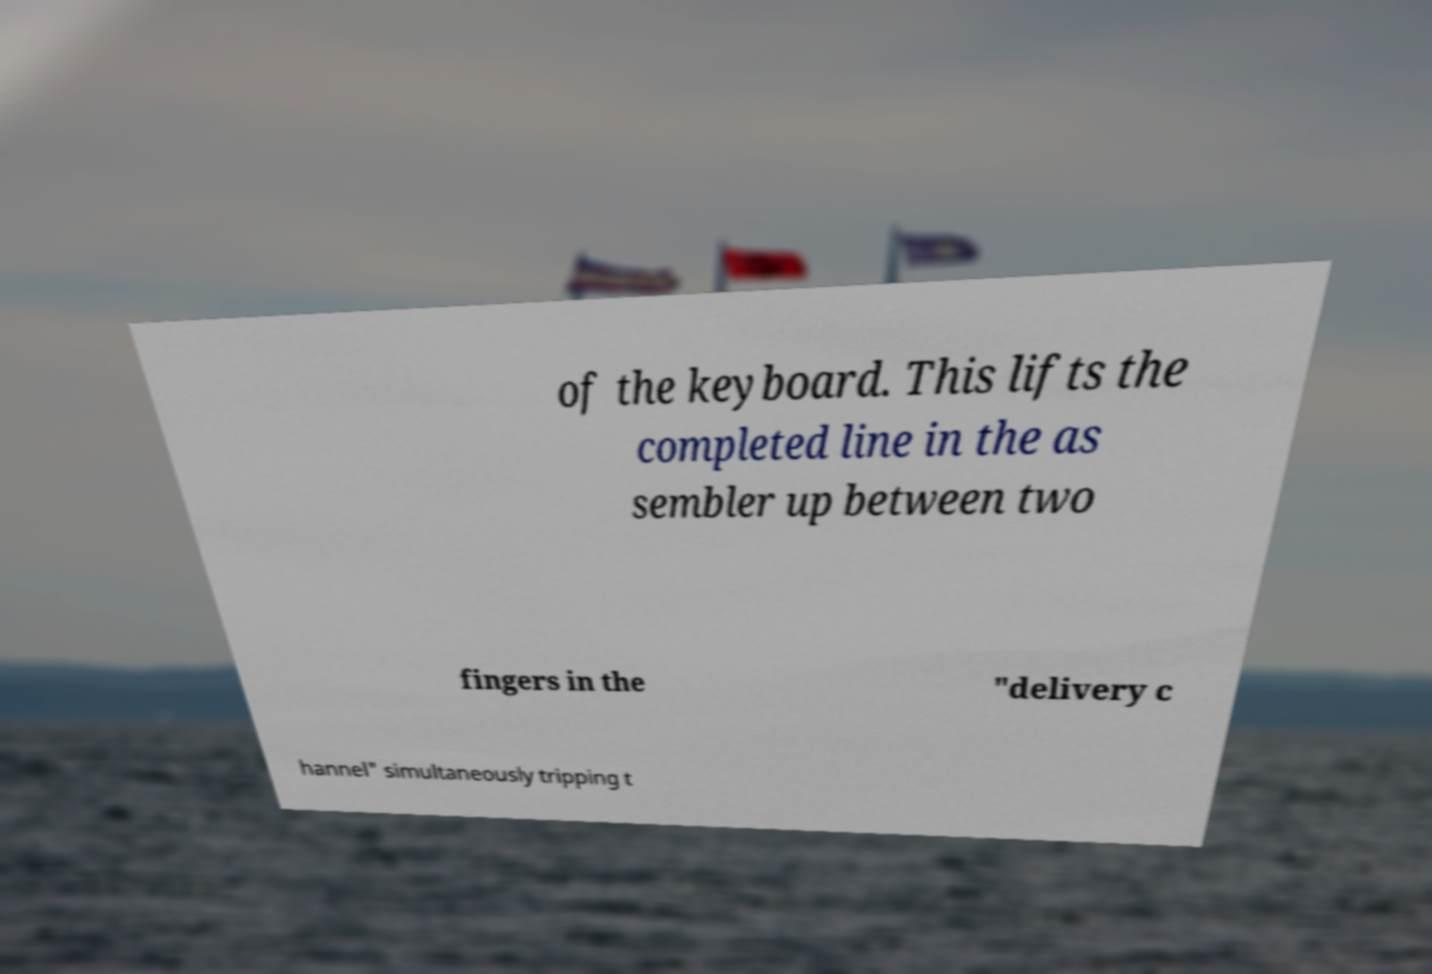There's text embedded in this image that I need extracted. Can you transcribe it verbatim? of the keyboard. This lifts the completed line in the as sembler up between two fingers in the "delivery c hannel" simultaneously tripping t 